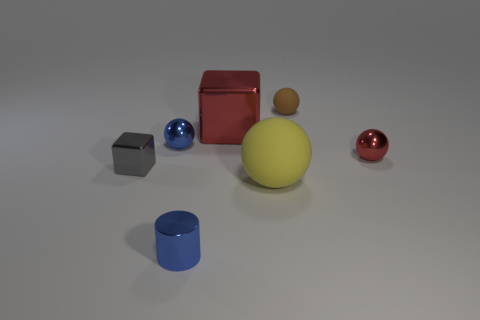Add 2 cylinders. How many objects exist? 9 Subtract all cubes. How many objects are left? 5 Subtract all tiny metal cubes. Subtract all red objects. How many objects are left? 4 Add 4 balls. How many balls are left? 8 Add 5 purple rubber cylinders. How many purple rubber cylinders exist? 5 Subtract 0 purple spheres. How many objects are left? 7 